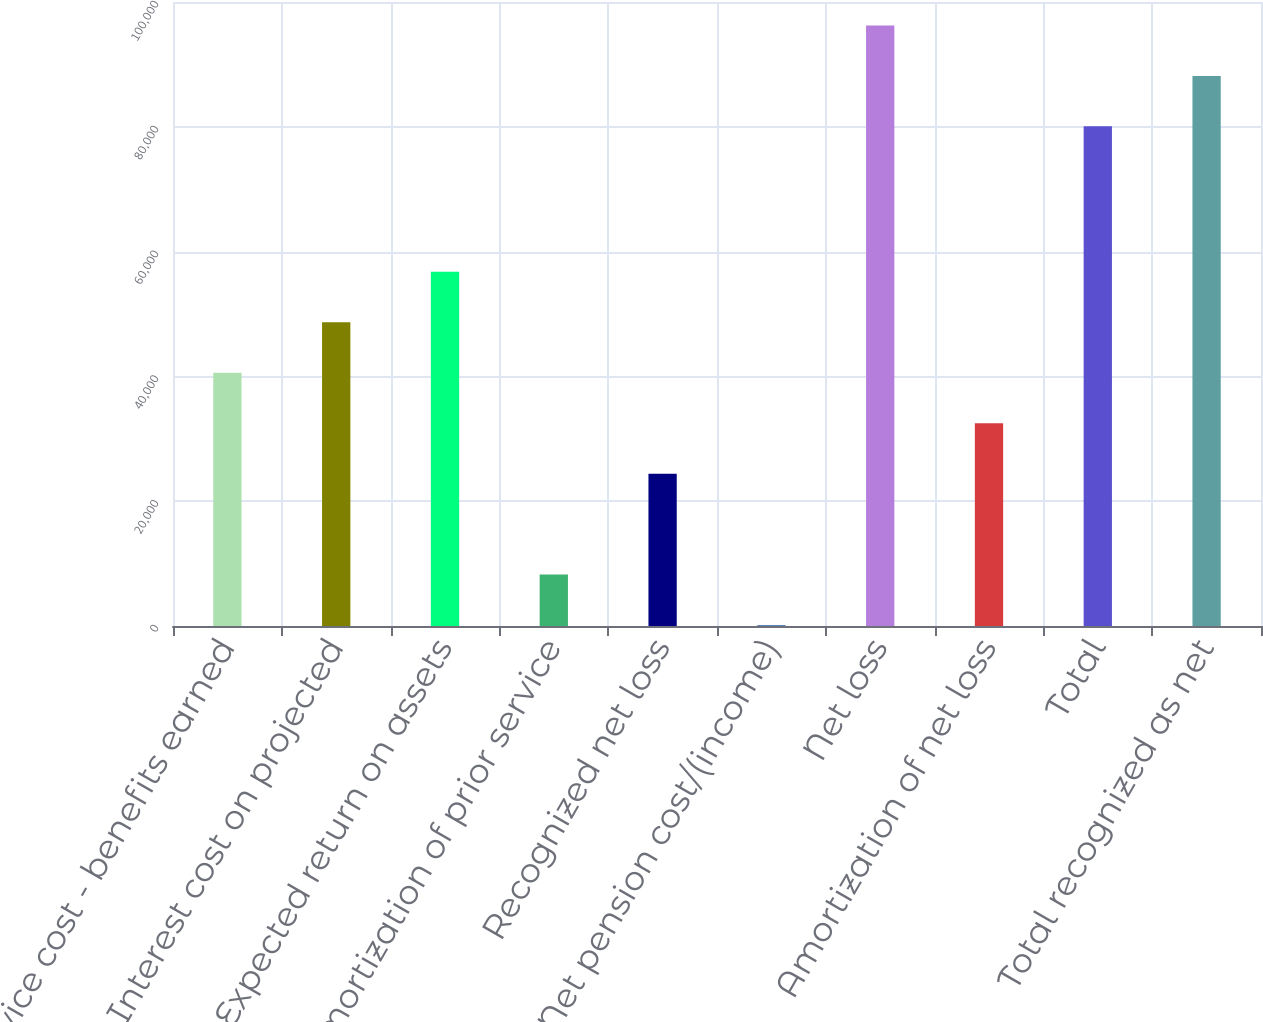Convert chart to OTSL. <chart><loc_0><loc_0><loc_500><loc_500><bar_chart><fcel>Service cost - benefits earned<fcel>Interest cost on projected<fcel>Expected return on assets<fcel>Amortization of prior service<fcel>Recognized net loss<fcel>Net pension cost/(income)<fcel>Net loss<fcel>Amortization of net loss<fcel>Total<fcel>Total recognized as net<nl><fcel>40586<fcel>48672<fcel>56758<fcel>8242<fcel>24414<fcel>156<fcel>96246<fcel>32500<fcel>80074<fcel>88160<nl></chart> 